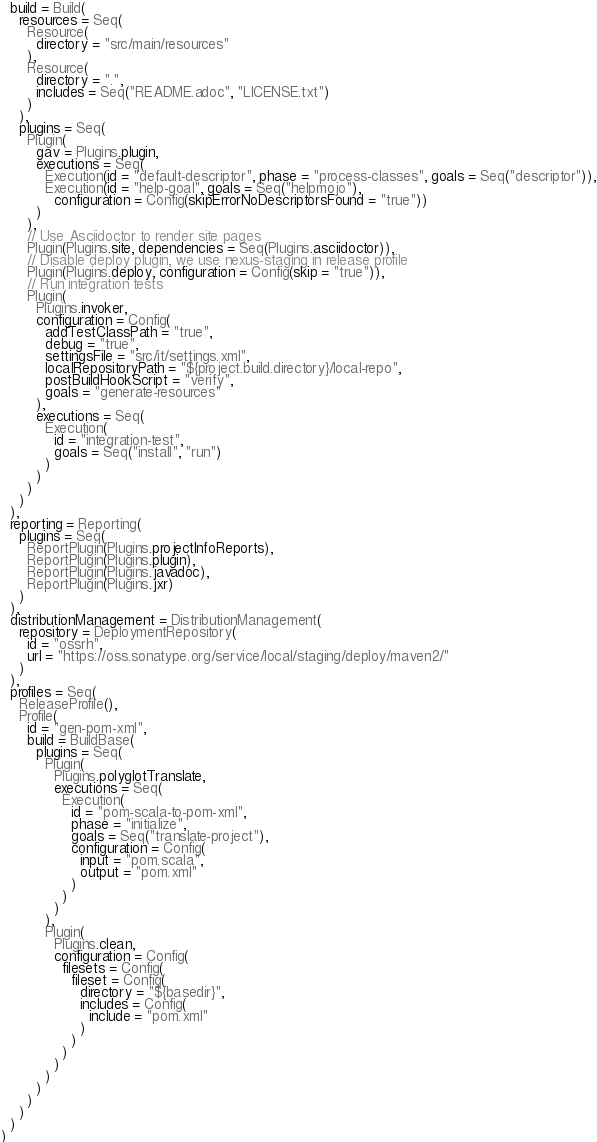<code> <loc_0><loc_0><loc_500><loc_500><_Scala_>  build = Build(
    resources = Seq(
      Resource(
        directory = "src/main/resources"
      ),
      Resource(
        directory = ".",
        includes = Seq("README.adoc", "LICENSE.txt")
      )
    ),
    plugins = Seq(
      Plugin(
        gav = Plugins.plugin,
        executions = Seq(
          Execution(id = "default-descriptor", phase = "process-classes", goals = Seq("descriptor")),
          Execution(id = "help-goal", goals = Seq("helpmojo"),
            configuration = Config(skipErrorNoDescriptorsFound = "true"))
        )
      ),
      // Use Asciidoctor to render site pages
      Plugin(Plugins.site, dependencies = Seq(Plugins.asciidoctor)),
      // Disable deploy plugin, we use nexus-staging in release profile
      Plugin(Plugins.deploy, configuration = Config(skip = "true")),
      // Run integration tests
      Plugin(
        Plugins.invoker,
        configuration = Config(
          addTestClassPath = "true",
          debug = "true",
          settingsFile = "src/it/settings.xml",
          localRepositoryPath = "${project.build.directory}/local-repo",
          postBuildHookScript = "verify",
          goals = "generate-resources"
        ),
        executions = Seq(
          Execution(
            id = "integration-test",
            goals = Seq("install", "run")
          )
        )
      )
    )
  ),
  reporting = Reporting(
    plugins = Seq(
      ReportPlugin(Plugins.projectInfoReports),
      ReportPlugin(Plugins.plugin),
      ReportPlugin(Plugins.javadoc),
      ReportPlugin(Plugins.jxr)
    )
  ),
  distributionManagement = DistributionManagement(
    repository = DeploymentRepository(
      id = "ossrh",
      url = "https://oss.sonatype.org/service/local/staging/deploy/maven2/"
    )
  ),
  profiles = Seq(
    ReleaseProfile(),
    Profile(
      id = "gen-pom-xml",
      build = BuildBase(
        plugins = Seq(
          Plugin(
            Plugins.polyglotTranslate,
            executions = Seq(
              Execution(
                id = "pom-scala-to-pom-xml",
                phase = "initialize",
                goals = Seq("translate-project"),
                configuration = Config(
                  input = "pom.scala",
                  output = "pom.xml"
                )
              )
            )
          ),
          Plugin(
            Plugins.clean,
            configuration = Config(
              filesets = Config(
                fileset = Config(
                  directory = "${basedir}",
                  includes = Config(
                    include = "pom.xml"
                  )
                )
              )
            )
          )
        )
      )
    )
  )
)
</code> 